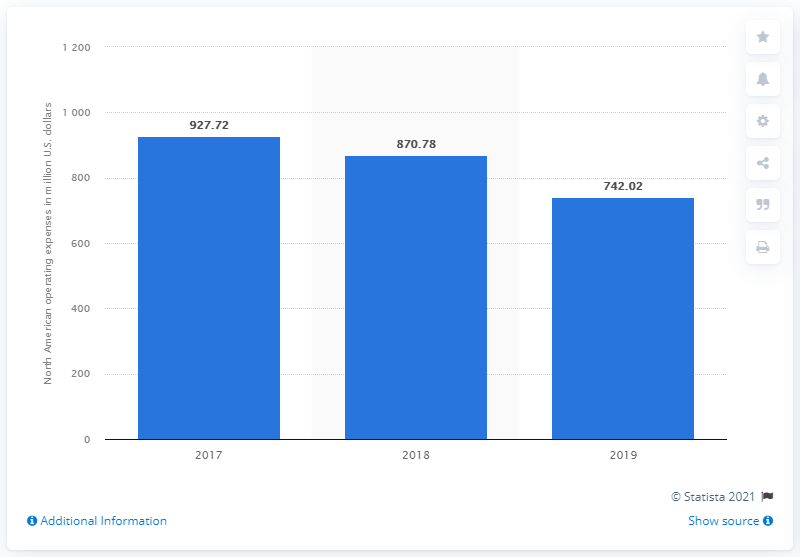Indicate a few pertinent items in this graphic. In 2017, Groupon's operating expenses in the United States and Canada were approximately $742.02. 